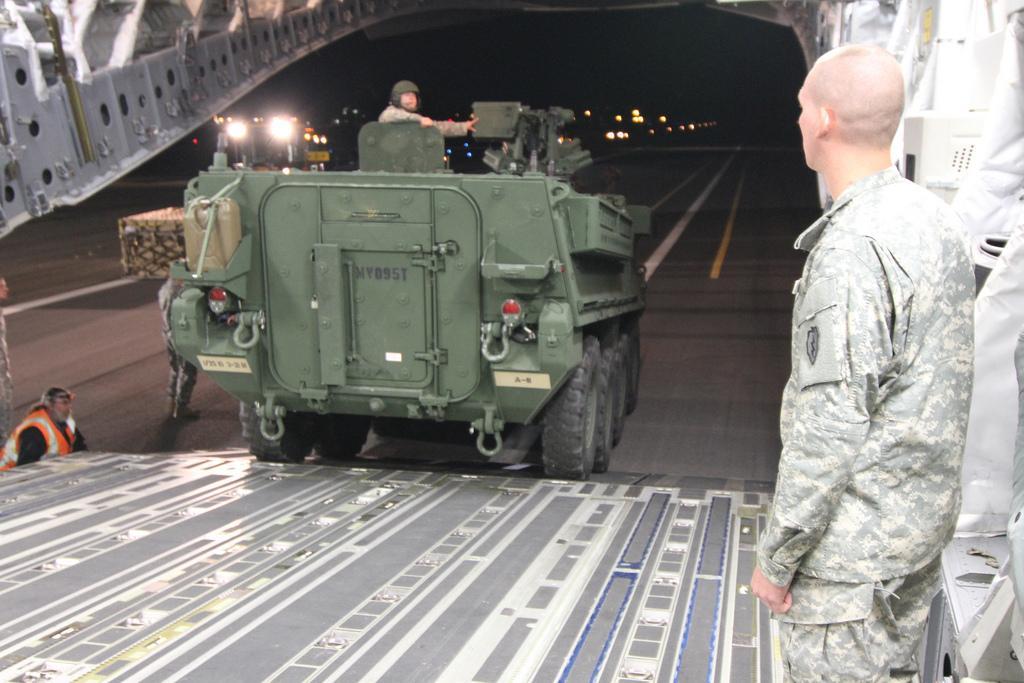Please provide a concise description of this image. In the foreground of this image, there is a war tank on which there is a person standing on it. On right, there is man standing in military dress and on left, there is a man. In the background, we see the path. 